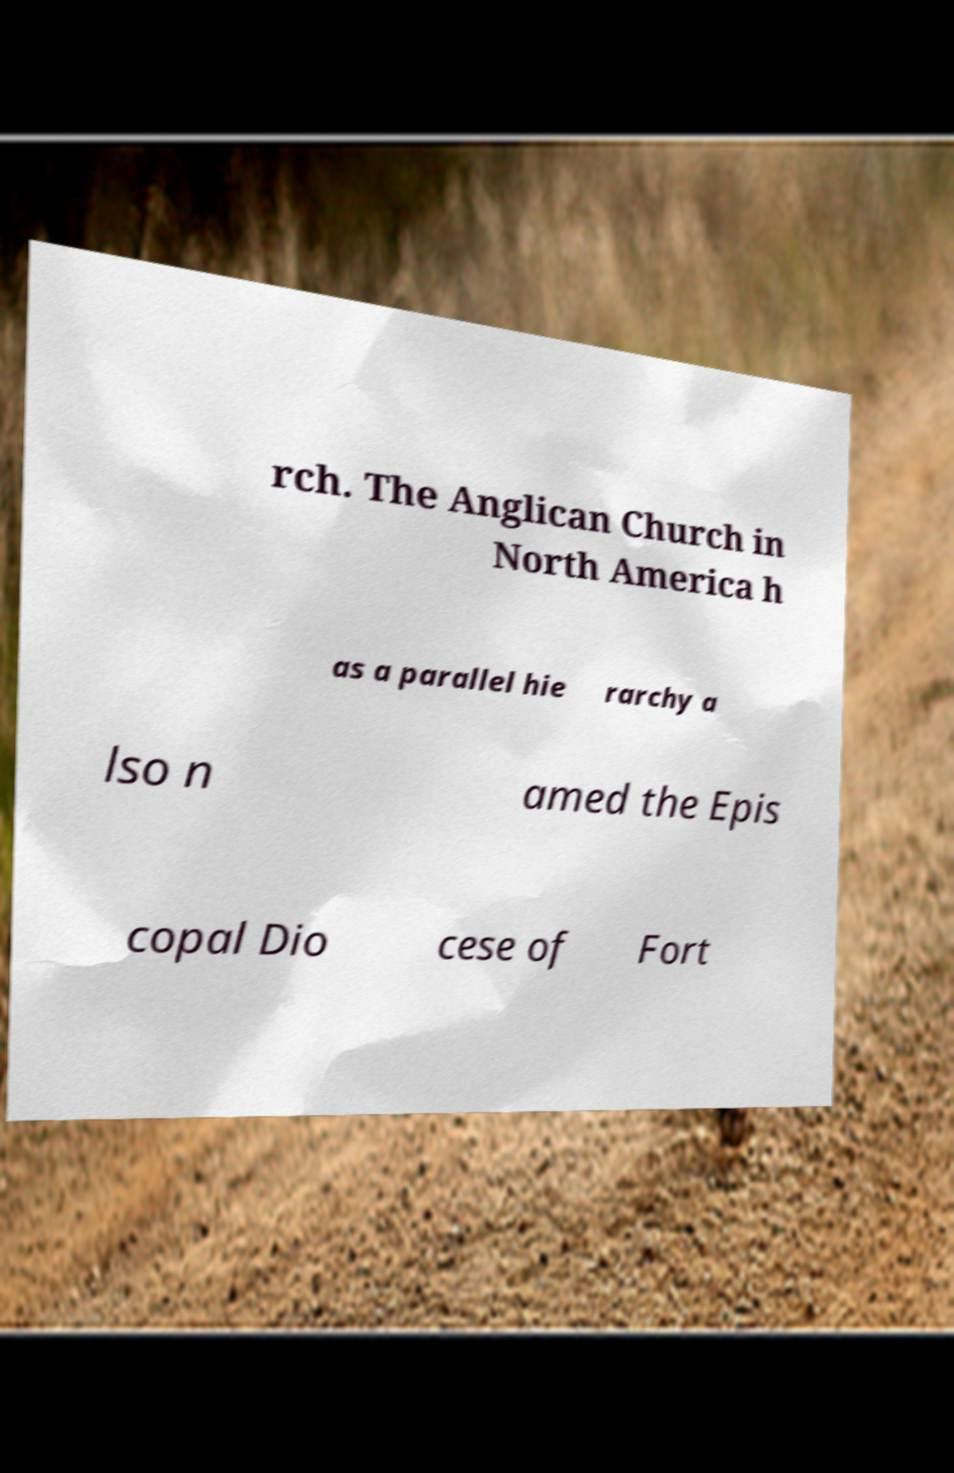What messages or text are displayed in this image? I need them in a readable, typed format. rch. The Anglican Church in North America h as a parallel hie rarchy a lso n amed the Epis copal Dio cese of Fort 